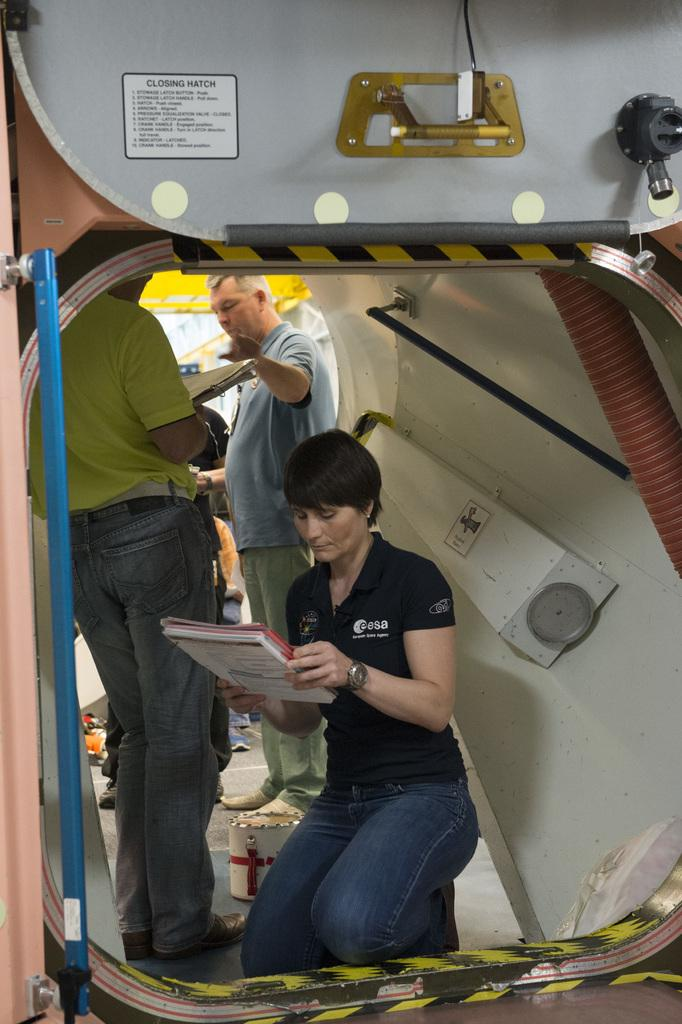How many people are in the image? There are people in the image, but the exact number is not specified. What is the person holding in the image? A person is holding an object in the image, but the specific object is not described. What type of structure is present in the image? There is a pipe in the image, which is a type of structure. What are the rods used for in the image? The purpose of the rods in the image is not specified. What is depicted on the poster in the image? There is a poster in the image, but its content is not described. What other objects can be seen in the image? There are other objects in the image, but their specific nature is not described. What type of degree is the person holding in the image? There is no mention of a degree in the image, as the person is holding an object, not a degree. Can you see any beetles or frogs in the image? There is no mention of beetles or frogs in the image; the facts only mention people, an object, a pipe, rods, a poster, and other objects. 